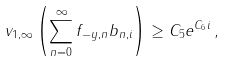Convert formula to latex. <formula><loc_0><loc_0><loc_500><loc_500>v _ { 1 , \infty } \left ( \sum _ { n = 0 } ^ { \infty } f _ { - y , n } b _ { n , i } \right ) \geq C _ { 5 } e ^ { C _ { 6 } i } \, ,</formula> 